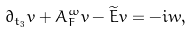Convert formula to latex. <formula><loc_0><loc_0><loc_500><loc_500>\partial _ { t _ { 3 } } v + A ^ { \omega } _ { F } v - \widetilde { E } v = - i w ,</formula> 